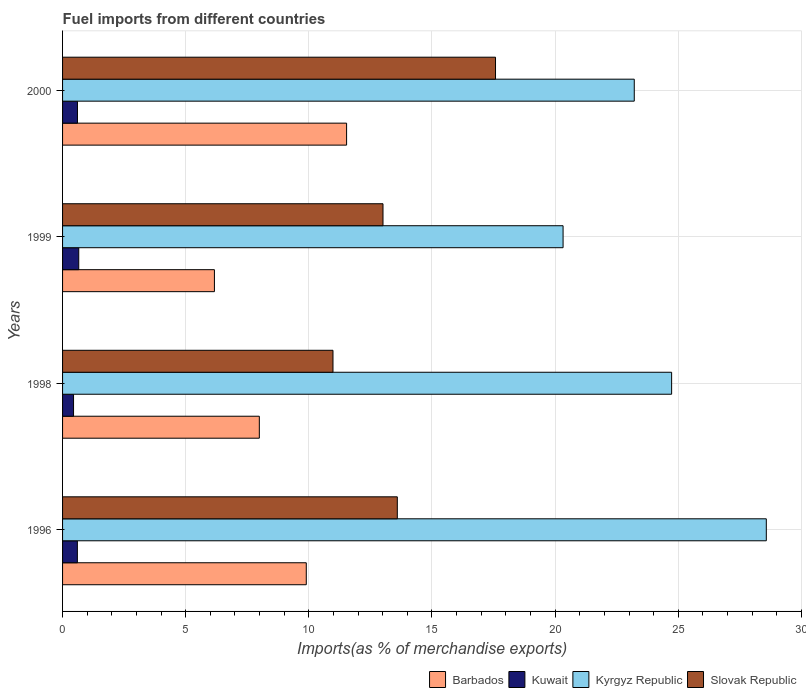How many different coloured bars are there?
Offer a very short reply. 4. Are the number of bars on each tick of the Y-axis equal?
Provide a succinct answer. Yes. How many bars are there on the 4th tick from the bottom?
Provide a short and direct response. 4. In how many cases, is the number of bars for a given year not equal to the number of legend labels?
Make the answer very short. 0. What is the percentage of imports to different countries in Barbados in 1996?
Your answer should be very brief. 9.9. Across all years, what is the maximum percentage of imports to different countries in Kyrgyz Republic?
Keep it short and to the point. 28.58. Across all years, what is the minimum percentage of imports to different countries in Slovak Republic?
Ensure brevity in your answer.  10.98. What is the total percentage of imports to different countries in Kyrgyz Republic in the graph?
Provide a succinct answer. 96.84. What is the difference between the percentage of imports to different countries in Kyrgyz Republic in 1996 and that in 1999?
Your response must be concise. 8.25. What is the difference between the percentage of imports to different countries in Kyrgyz Republic in 1996 and the percentage of imports to different countries in Barbados in 1999?
Your answer should be compact. 22.41. What is the average percentage of imports to different countries in Slovak Republic per year?
Ensure brevity in your answer.  13.79. In the year 2000, what is the difference between the percentage of imports to different countries in Slovak Republic and percentage of imports to different countries in Kuwait?
Keep it short and to the point. 16.97. What is the ratio of the percentage of imports to different countries in Kyrgyz Republic in 1996 to that in 2000?
Your answer should be very brief. 1.23. Is the percentage of imports to different countries in Slovak Republic in 1999 less than that in 2000?
Keep it short and to the point. Yes. Is the difference between the percentage of imports to different countries in Slovak Republic in 1998 and 2000 greater than the difference between the percentage of imports to different countries in Kuwait in 1998 and 2000?
Ensure brevity in your answer.  No. What is the difference between the highest and the second highest percentage of imports to different countries in Kuwait?
Your answer should be compact. 0.05. What is the difference between the highest and the lowest percentage of imports to different countries in Kyrgyz Republic?
Ensure brevity in your answer.  8.25. What does the 4th bar from the top in 1998 represents?
Make the answer very short. Barbados. What does the 1st bar from the bottom in 1996 represents?
Ensure brevity in your answer.  Barbados. How many bars are there?
Your response must be concise. 16. What is the title of the graph?
Ensure brevity in your answer.  Fuel imports from different countries. Does "Equatorial Guinea" appear as one of the legend labels in the graph?
Your answer should be very brief. No. What is the label or title of the X-axis?
Keep it short and to the point. Imports(as % of merchandise exports). What is the label or title of the Y-axis?
Offer a very short reply. Years. What is the Imports(as % of merchandise exports) of Barbados in 1996?
Offer a very short reply. 9.9. What is the Imports(as % of merchandise exports) in Kuwait in 1996?
Keep it short and to the point. 0.6. What is the Imports(as % of merchandise exports) of Kyrgyz Republic in 1996?
Provide a short and direct response. 28.58. What is the Imports(as % of merchandise exports) in Slovak Republic in 1996?
Keep it short and to the point. 13.59. What is the Imports(as % of merchandise exports) in Barbados in 1998?
Provide a short and direct response. 7.99. What is the Imports(as % of merchandise exports) of Kuwait in 1998?
Keep it short and to the point. 0.45. What is the Imports(as % of merchandise exports) in Kyrgyz Republic in 1998?
Provide a short and direct response. 24.73. What is the Imports(as % of merchandise exports) in Slovak Republic in 1998?
Your answer should be compact. 10.98. What is the Imports(as % of merchandise exports) of Barbados in 1999?
Your response must be concise. 6.17. What is the Imports(as % of merchandise exports) of Kuwait in 1999?
Ensure brevity in your answer.  0.66. What is the Imports(as % of merchandise exports) in Kyrgyz Republic in 1999?
Give a very brief answer. 20.32. What is the Imports(as % of merchandise exports) of Slovak Republic in 1999?
Provide a succinct answer. 13.01. What is the Imports(as % of merchandise exports) of Barbados in 2000?
Offer a very short reply. 11.53. What is the Imports(as % of merchandise exports) of Kuwait in 2000?
Your answer should be very brief. 0.61. What is the Imports(as % of merchandise exports) in Kyrgyz Republic in 2000?
Your answer should be very brief. 23.21. What is the Imports(as % of merchandise exports) in Slovak Republic in 2000?
Keep it short and to the point. 17.58. Across all years, what is the maximum Imports(as % of merchandise exports) of Barbados?
Your response must be concise. 11.53. Across all years, what is the maximum Imports(as % of merchandise exports) of Kuwait?
Offer a very short reply. 0.66. Across all years, what is the maximum Imports(as % of merchandise exports) of Kyrgyz Republic?
Offer a very short reply. 28.58. Across all years, what is the maximum Imports(as % of merchandise exports) in Slovak Republic?
Offer a very short reply. 17.58. Across all years, what is the minimum Imports(as % of merchandise exports) of Barbados?
Your answer should be very brief. 6.17. Across all years, what is the minimum Imports(as % of merchandise exports) of Kuwait?
Your answer should be compact. 0.45. Across all years, what is the minimum Imports(as % of merchandise exports) of Kyrgyz Republic?
Provide a short and direct response. 20.32. Across all years, what is the minimum Imports(as % of merchandise exports) of Slovak Republic?
Provide a succinct answer. 10.98. What is the total Imports(as % of merchandise exports) in Barbados in the graph?
Give a very brief answer. 35.59. What is the total Imports(as % of merchandise exports) in Kuwait in the graph?
Your answer should be very brief. 2.31. What is the total Imports(as % of merchandise exports) of Kyrgyz Republic in the graph?
Offer a terse response. 96.84. What is the total Imports(as % of merchandise exports) of Slovak Republic in the graph?
Make the answer very short. 55.16. What is the difference between the Imports(as % of merchandise exports) of Barbados in 1996 and that in 1998?
Ensure brevity in your answer.  1.91. What is the difference between the Imports(as % of merchandise exports) in Kuwait in 1996 and that in 1998?
Your answer should be compact. 0.16. What is the difference between the Imports(as % of merchandise exports) of Kyrgyz Republic in 1996 and that in 1998?
Your answer should be compact. 3.84. What is the difference between the Imports(as % of merchandise exports) of Slovak Republic in 1996 and that in 1998?
Provide a succinct answer. 2.61. What is the difference between the Imports(as % of merchandise exports) of Barbados in 1996 and that in 1999?
Keep it short and to the point. 3.73. What is the difference between the Imports(as % of merchandise exports) of Kuwait in 1996 and that in 1999?
Give a very brief answer. -0.06. What is the difference between the Imports(as % of merchandise exports) in Kyrgyz Republic in 1996 and that in 1999?
Keep it short and to the point. 8.25. What is the difference between the Imports(as % of merchandise exports) of Slovak Republic in 1996 and that in 1999?
Give a very brief answer. 0.58. What is the difference between the Imports(as % of merchandise exports) in Barbados in 1996 and that in 2000?
Make the answer very short. -1.64. What is the difference between the Imports(as % of merchandise exports) in Kuwait in 1996 and that in 2000?
Provide a short and direct response. -0. What is the difference between the Imports(as % of merchandise exports) of Kyrgyz Republic in 1996 and that in 2000?
Your response must be concise. 5.36. What is the difference between the Imports(as % of merchandise exports) in Slovak Republic in 1996 and that in 2000?
Ensure brevity in your answer.  -3.99. What is the difference between the Imports(as % of merchandise exports) of Barbados in 1998 and that in 1999?
Ensure brevity in your answer.  1.82. What is the difference between the Imports(as % of merchandise exports) of Kuwait in 1998 and that in 1999?
Give a very brief answer. -0.21. What is the difference between the Imports(as % of merchandise exports) of Kyrgyz Republic in 1998 and that in 1999?
Offer a very short reply. 4.41. What is the difference between the Imports(as % of merchandise exports) in Slovak Republic in 1998 and that in 1999?
Keep it short and to the point. -2.03. What is the difference between the Imports(as % of merchandise exports) of Barbados in 1998 and that in 2000?
Offer a very short reply. -3.54. What is the difference between the Imports(as % of merchandise exports) in Kuwait in 1998 and that in 2000?
Make the answer very short. -0.16. What is the difference between the Imports(as % of merchandise exports) of Kyrgyz Republic in 1998 and that in 2000?
Your response must be concise. 1.52. What is the difference between the Imports(as % of merchandise exports) of Slovak Republic in 1998 and that in 2000?
Give a very brief answer. -6.6. What is the difference between the Imports(as % of merchandise exports) in Barbados in 1999 and that in 2000?
Your answer should be compact. -5.37. What is the difference between the Imports(as % of merchandise exports) in Kuwait in 1999 and that in 2000?
Provide a short and direct response. 0.05. What is the difference between the Imports(as % of merchandise exports) of Kyrgyz Republic in 1999 and that in 2000?
Offer a very short reply. -2.89. What is the difference between the Imports(as % of merchandise exports) in Slovak Republic in 1999 and that in 2000?
Your answer should be compact. -4.57. What is the difference between the Imports(as % of merchandise exports) of Barbados in 1996 and the Imports(as % of merchandise exports) of Kuwait in 1998?
Your answer should be very brief. 9.45. What is the difference between the Imports(as % of merchandise exports) of Barbados in 1996 and the Imports(as % of merchandise exports) of Kyrgyz Republic in 1998?
Keep it short and to the point. -14.83. What is the difference between the Imports(as % of merchandise exports) of Barbados in 1996 and the Imports(as % of merchandise exports) of Slovak Republic in 1998?
Keep it short and to the point. -1.08. What is the difference between the Imports(as % of merchandise exports) in Kuwait in 1996 and the Imports(as % of merchandise exports) in Kyrgyz Republic in 1998?
Provide a succinct answer. -24.13. What is the difference between the Imports(as % of merchandise exports) in Kuwait in 1996 and the Imports(as % of merchandise exports) in Slovak Republic in 1998?
Ensure brevity in your answer.  -10.38. What is the difference between the Imports(as % of merchandise exports) of Kyrgyz Republic in 1996 and the Imports(as % of merchandise exports) of Slovak Republic in 1998?
Keep it short and to the point. 17.59. What is the difference between the Imports(as % of merchandise exports) in Barbados in 1996 and the Imports(as % of merchandise exports) in Kuwait in 1999?
Your answer should be very brief. 9.24. What is the difference between the Imports(as % of merchandise exports) in Barbados in 1996 and the Imports(as % of merchandise exports) in Kyrgyz Republic in 1999?
Your response must be concise. -10.43. What is the difference between the Imports(as % of merchandise exports) of Barbados in 1996 and the Imports(as % of merchandise exports) of Slovak Republic in 1999?
Your answer should be compact. -3.12. What is the difference between the Imports(as % of merchandise exports) in Kuwait in 1996 and the Imports(as % of merchandise exports) in Kyrgyz Republic in 1999?
Give a very brief answer. -19.72. What is the difference between the Imports(as % of merchandise exports) in Kuwait in 1996 and the Imports(as % of merchandise exports) in Slovak Republic in 1999?
Your answer should be compact. -12.41. What is the difference between the Imports(as % of merchandise exports) of Kyrgyz Republic in 1996 and the Imports(as % of merchandise exports) of Slovak Republic in 1999?
Provide a succinct answer. 15.56. What is the difference between the Imports(as % of merchandise exports) in Barbados in 1996 and the Imports(as % of merchandise exports) in Kuwait in 2000?
Keep it short and to the point. 9.29. What is the difference between the Imports(as % of merchandise exports) of Barbados in 1996 and the Imports(as % of merchandise exports) of Kyrgyz Republic in 2000?
Your answer should be compact. -13.32. What is the difference between the Imports(as % of merchandise exports) in Barbados in 1996 and the Imports(as % of merchandise exports) in Slovak Republic in 2000?
Ensure brevity in your answer.  -7.68. What is the difference between the Imports(as % of merchandise exports) in Kuwait in 1996 and the Imports(as % of merchandise exports) in Kyrgyz Republic in 2000?
Give a very brief answer. -22.61. What is the difference between the Imports(as % of merchandise exports) in Kuwait in 1996 and the Imports(as % of merchandise exports) in Slovak Republic in 2000?
Your answer should be very brief. -16.98. What is the difference between the Imports(as % of merchandise exports) of Kyrgyz Republic in 1996 and the Imports(as % of merchandise exports) of Slovak Republic in 2000?
Provide a succinct answer. 11. What is the difference between the Imports(as % of merchandise exports) of Barbados in 1998 and the Imports(as % of merchandise exports) of Kuwait in 1999?
Your response must be concise. 7.33. What is the difference between the Imports(as % of merchandise exports) of Barbados in 1998 and the Imports(as % of merchandise exports) of Kyrgyz Republic in 1999?
Offer a very short reply. -12.33. What is the difference between the Imports(as % of merchandise exports) of Barbados in 1998 and the Imports(as % of merchandise exports) of Slovak Republic in 1999?
Your answer should be very brief. -5.02. What is the difference between the Imports(as % of merchandise exports) of Kuwait in 1998 and the Imports(as % of merchandise exports) of Kyrgyz Republic in 1999?
Keep it short and to the point. -19.88. What is the difference between the Imports(as % of merchandise exports) in Kuwait in 1998 and the Imports(as % of merchandise exports) in Slovak Republic in 1999?
Make the answer very short. -12.57. What is the difference between the Imports(as % of merchandise exports) of Kyrgyz Republic in 1998 and the Imports(as % of merchandise exports) of Slovak Republic in 1999?
Offer a terse response. 11.72. What is the difference between the Imports(as % of merchandise exports) in Barbados in 1998 and the Imports(as % of merchandise exports) in Kuwait in 2000?
Your response must be concise. 7.38. What is the difference between the Imports(as % of merchandise exports) in Barbados in 1998 and the Imports(as % of merchandise exports) in Kyrgyz Republic in 2000?
Give a very brief answer. -15.22. What is the difference between the Imports(as % of merchandise exports) in Barbados in 1998 and the Imports(as % of merchandise exports) in Slovak Republic in 2000?
Make the answer very short. -9.59. What is the difference between the Imports(as % of merchandise exports) in Kuwait in 1998 and the Imports(as % of merchandise exports) in Kyrgyz Republic in 2000?
Your answer should be very brief. -22.77. What is the difference between the Imports(as % of merchandise exports) in Kuwait in 1998 and the Imports(as % of merchandise exports) in Slovak Republic in 2000?
Provide a succinct answer. -17.13. What is the difference between the Imports(as % of merchandise exports) of Kyrgyz Republic in 1998 and the Imports(as % of merchandise exports) of Slovak Republic in 2000?
Give a very brief answer. 7.15. What is the difference between the Imports(as % of merchandise exports) in Barbados in 1999 and the Imports(as % of merchandise exports) in Kuwait in 2000?
Your response must be concise. 5.56. What is the difference between the Imports(as % of merchandise exports) of Barbados in 1999 and the Imports(as % of merchandise exports) of Kyrgyz Republic in 2000?
Offer a very short reply. -17.05. What is the difference between the Imports(as % of merchandise exports) of Barbados in 1999 and the Imports(as % of merchandise exports) of Slovak Republic in 2000?
Make the answer very short. -11.41. What is the difference between the Imports(as % of merchandise exports) in Kuwait in 1999 and the Imports(as % of merchandise exports) in Kyrgyz Republic in 2000?
Make the answer very short. -22.56. What is the difference between the Imports(as % of merchandise exports) of Kuwait in 1999 and the Imports(as % of merchandise exports) of Slovak Republic in 2000?
Offer a very short reply. -16.92. What is the difference between the Imports(as % of merchandise exports) in Kyrgyz Republic in 1999 and the Imports(as % of merchandise exports) in Slovak Republic in 2000?
Keep it short and to the point. 2.74. What is the average Imports(as % of merchandise exports) of Barbados per year?
Provide a short and direct response. 8.9. What is the average Imports(as % of merchandise exports) in Kuwait per year?
Offer a very short reply. 0.58. What is the average Imports(as % of merchandise exports) of Kyrgyz Republic per year?
Ensure brevity in your answer.  24.21. What is the average Imports(as % of merchandise exports) of Slovak Republic per year?
Keep it short and to the point. 13.79. In the year 1996, what is the difference between the Imports(as % of merchandise exports) in Barbados and Imports(as % of merchandise exports) in Kuwait?
Offer a terse response. 9.29. In the year 1996, what is the difference between the Imports(as % of merchandise exports) of Barbados and Imports(as % of merchandise exports) of Kyrgyz Republic?
Keep it short and to the point. -18.68. In the year 1996, what is the difference between the Imports(as % of merchandise exports) in Barbados and Imports(as % of merchandise exports) in Slovak Republic?
Keep it short and to the point. -3.7. In the year 1996, what is the difference between the Imports(as % of merchandise exports) of Kuwait and Imports(as % of merchandise exports) of Kyrgyz Republic?
Give a very brief answer. -27.97. In the year 1996, what is the difference between the Imports(as % of merchandise exports) in Kuwait and Imports(as % of merchandise exports) in Slovak Republic?
Provide a short and direct response. -12.99. In the year 1996, what is the difference between the Imports(as % of merchandise exports) of Kyrgyz Republic and Imports(as % of merchandise exports) of Slovak Republic?
Offer a very short reply. 14.98. In the year 1998, what is the difference between the Imports(as % of merchandise exports) in Barbados and Imports(as % of merchandise exports) in Kuwait?
Provide a short and direct response. 7.54. In the year 1998, what is the difference between the Imports(as % of merchandise exports) in Barbados and Imports(as % of merchandise exports) in Kyrgyz Republic?
Ensure brevity in your answer.  -16.74. In the year 1998, what is the difference between the Imports(as % of merchandise exports) in Barbados and Imports(as % of merchandise exports) in Slovak Republic?
Offer a terse response. -2.99. In the year 1998, what is the difference between the Imports(as % of merchandise exports) of Kuwait and Imports(as % of merchandise exports) of Kyrgyz Republic?
Provide a succinct answer. -24.28. In the year 1998, what is the difference between the Imports(as % of merchandise exports) in Kuwait and Imports(as % of merchandise exports) in Slovak Republic?
Your answer should be compact. -10.53. In the year 1998, what is the difference between the Imports(as % of merchandise exports) in Kyrgyz Republic and Imports(as % of merchandise exports) in Slovak Republic?
Offer a terse response. 13.75. In the year 1999, what is the difference between the Imports(as % of merchandise exports) in Barbados and Imports(as % of merchandise exports) in Kuwait?
Your response must be concise. 5.51. In the year 1999, what is the difference between the Imports(as % of merchandise exports) of Barbados and Imports(as % of merchandise exports) of Kyrgyz Republic?
Your response must be concise. -14.16. In the year 1999, what is the difference between the Imports(as % of merchandise exports) of Barbados and Imports(as % of merchandise exports) of Slovak Republic?
Your answer should be compact. -6.84. In the year 1999, what is the difference between the Imports(as % of merchandise exports) of Kuwait and Imports(as % of merchandise exports) of Kyrgyz Republic?
Your answer should be compact. -19.67. In the year 1999, what is the difference between the Imports(as % of merchandise exports) of Kuwait and Imports(as % of merchandise exports) of Slovak Republic?
Your response must be concise. -12.35. In the year 1999, what is the difference between the Imports(as % of merchandise exports) in Kyrgyz Republic and Imports(as % of merchandise exports) in Slovak Republic?
Your answer should be very brief. 7.31. In the year 2000, what is the difference between the Imports(as % of merchandise exports) in Barbados and Imports(as % of merchandise exports) in Kuwait?
Offer a terse response. 10.93. In the year 2000, what is the difference between the Imports(as % of merchandise exports) of Barbados and Imports(as % of merchandise exports) of Kyrgyz Republic?
Your answer should be very brief. -11.68. In the year 2000, what is the difference between the Imports(as % of merchandise exports) of Barbados and Imports(as % of merchandise exports) of Slovak Republic?
Your answer should be compact. -6.05. In the year 2000, what is the difference between the Imports(as % of merchandise exports) in Kuwait and Imports(as % of merchandise exports) in Kyrgyz Republic?
Your answer should be compact. -22.61. In the year 2000, what is the difference between the Imports(as % of merchandise exports) of Kuwait and Imports(as % of merchandise exports) of Slovak Republic?
Your response must be concise. -16.97. In the year 2000, what is the difference between the Imports(as % of merchandise exports) of Kyrgyz Republic and Imports(as % of merchandise exports) of Slovak Republic?
Keep it short and to the point. 5.63. What is the ratio of the Imports(as % of merchandise exports) of Barbados in 1996 to that in 1998?
Give a very brief answer. 1.24. What is the ratio of the Imports(as % of merchandise exports) in Kuwait in 1996 to that in 1998?
Give a very brief answer. 1.35. What is the ratio of the Imports(as % of merchandise exports) of Kyrgyz Republic in 1996 to that in 1998?
Make the answer very short. 1.16. What is the ratio of the Imports(as % of merchandise exports) of Slovak Republic in 1996 to that in 1998?
Ensure brevity in your answer.  1.24. What is the ratio of the Imports(as % of merchandise exports) of Barbados in 1996 to that in 1999?
Offer a very short reply. 1.6. What is the ratio of the Imports(as % of merchandise exports) of Kuwait in 1996 to that in 1999?
Offer a very short reply. 0.91. What is the ratio of the Imports(as % of merchandise exports) of Kyrgyz Republic in 1996 to that in 1999?
Provide a succinct answer. 1.41. What is the ratio of the Imports(as % of merchandise exports) of Slovak Republic in 1996 to that in 1999?
Ensure brevity in your answer.  1.04. What is the ratio of the Imports(as % of merchandise exports) in Barbados in 1996 to that in 2000?
Your answer should be compact. 0.86. What is the ratio of the Imports(as % of merchandise exports) in Kuwait in 1996 to that in 2000?
Give a very brief answer. 0.99. What is the ratio of the Imports(as % of merchandise exports) of Kyrgyz Republic in 1996 to that in 2000?
Your response must be concise. 1.23. What is the ratio of the Imports(as % of merchandise exports) of Slovak Republic in 1996 to that in 2000?
Your answer should be compact. 0.77. What is the ratio of the Imports(as % of merchandise exports) in Barbados in 1998 to that in 1999?
Give a very brief answer. 1.3. What is the ratio of the Imports(as % of merchandise exports) in Kuwait in 1998 to that in 1999?
Your answer should be compact. 0.68. What is the ratio of the Imports(as % of merchandise exports) in Kyrgyz Republic in 1998 to that in 1999?
Your answer should be compact. 1.22. What is the ratio of the Imports(as % of merchandise exports) in Slovak Republic in 1998 to that in 1999?
Your response must be concise. 0.84. What is the ratio of the Imports(as % of merchandise exports) of Barbados in 1998 to that in 2000?
Offer a terse response. 0.69. What is the ratio of the Imports(as % of merchandise exports) in Kuwait in 1998 to that in 2000?
Keep it short and to the point. 0.74. What is the ratio of the Imports(as % of merchandise exports) in Kyrgyz Republic in 1998 to that in 2000?
Offer a terse response. 1.07. What is the ratio of the Imports(as % of merchandise exports) in Slovak Republic in 1998 to that in 2000?
Your answer should be compact. 0.62. What is the ratio of the Imports(as % of merchandise exports) in Barbados in 1999 to that in 2000?
Make the answer very short. 0.53. What is the ratio of the Imports(as % of merchandise exports) in Kuwait in 1999 to that in 2000?
Offer a very short reply. 1.09. What is the ratio of the Imports(as % of merchandise exports) in Kyrgyz Republic in 1999 to that in 2000?
Offer a very short reply. 0.88. What is the ratio of the Imports(as % of merchandise exports) of Slovak Republic in 1999 to that in 2000?
Offer a terse response. 0.74. What is the difference between the highest and the second highest Imports(as % of merchandise exports) in Barbados?
Your answer should be compact. 1.64. What is the difference between the highest and the second highest Imports(as % of merchandise exports) in Kuwait?
Ensure brevity in your answer.  0.05. What is the difference between the highest and the second highest Imports(as % of merchandise exports) of Kyrgyz Republic?
Keep it short and to the point. 3.84. What is the difference between the highest and the second highest Imports(as % of merchandise exports) of Slovak Republic?
Offer a terse response. 3.99. What is the difference between the highest and the lowest Imports(as % of merchandise exports) in Barbados?
Your answer should be very brief. 5.37. What is the difference between the highest and the lowest Imports(as % of merchandise exports) in Kuwait?
Ensure brevity in your answer.  0.21. What is the difference between the highest and the lowest Imports(as % of merchandise exports) in Kyrgyz Republic?
Provide a short and direct response. 8.25. What is the difference between the highest and the lowest Imports(as % of merchandise exports) in Slovak Republic?
Your answer should be very brief. 6.6. 